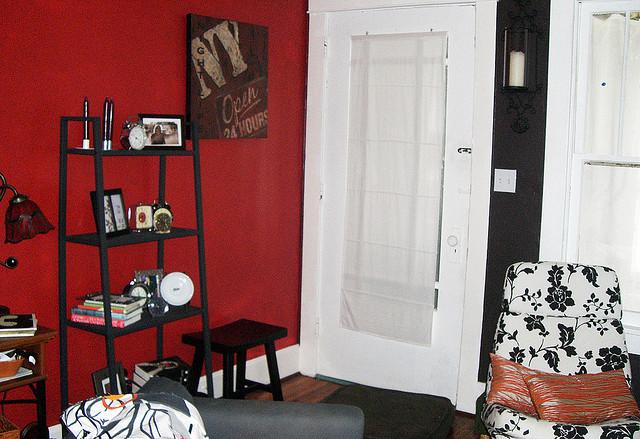How many books are on the shelf?
Quick response, please. 4. What color is the bright wall?
Write a very short answer. Red. Is there anyone in the room?
Short answer required. No. 